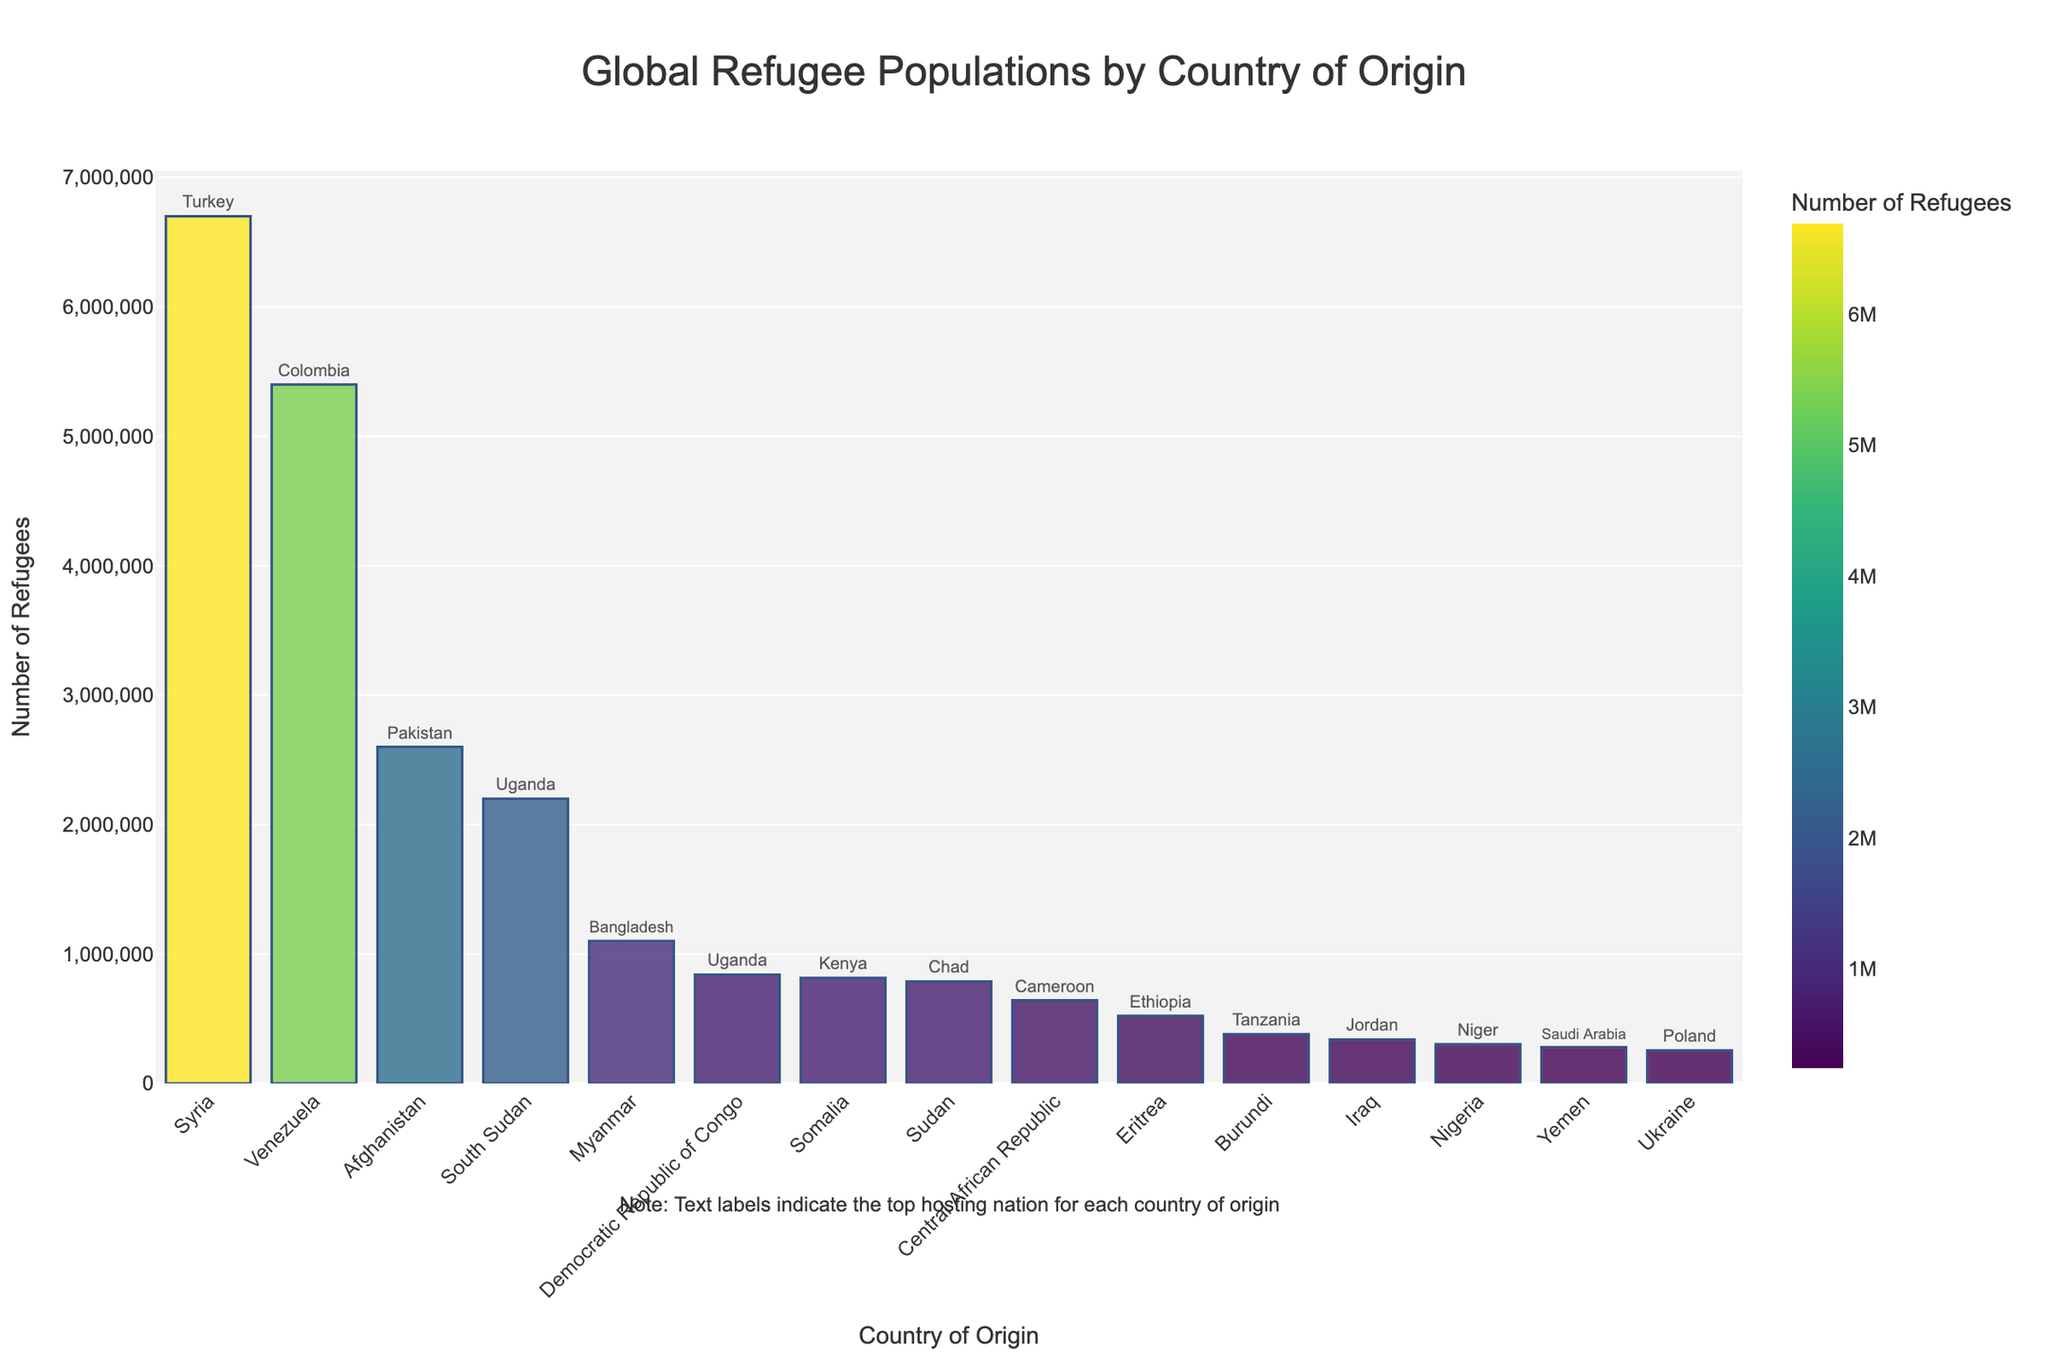What is the country of origin with the highest number of refugees? The bar chart shows that Syria has the highest number of refugees. This is evident from the tallest bar representing Syria.
Answer: Syria Which country of origin has the second largest number of refugees? The bar chart indicates that Venezuela has the second largest number of refugees by having the second tallest bar.
Answer: Venezuela How many more refugees are there from Syria compared to Afghanistan? From the bar chart, Syria has 6,700,000 refugees, and Afghanistan has 2,600,000 refugees. Subtracting these gives 6,700,000 - 2,600,000 = 4,100,000 more refugees from Syria.
Answer: 4,100,000 Which countries of origin have fewer than 1,000,000 refugees? The countries with bars shorter than those for South Sudan are Democratic Republic of Congo, Somalia, Sudan, Central African Republic, Eritrea, Burundi, Iraq, Nigeria, Yemen, and Ukraine.
Answer: Democratic Republic of Congo, Somalia, Sudan, Central African Republic, Eritrea, Burundi, Iraq, Nigeria, Yemen, Ukraine Among the countries listed, which top hosting nation has the highest number of refugees? The bar representing Syria indicates Turkey as the top hosting nation, with 6,700,000 refugees. Checking the other bars, this is indeed the highest figure for hosting refugees.
Answer: Turkey What is the difference in the refugee population between Myanmar and Sudan? Myanmar has 1,100,000 refugees, whereas Sudan has 788,000 refugees. The difference is 1,100,000 - 788,000 = 312,000 refugees.
Answer: 312,000 What is the total number of refugees from South Sudan and Democratic Republic of Congo combined? The bar chart shows South Sudan has 2,200,000 refugees, and Democratic Republic of Congo has 840,000 refugees. Adding these, 2,200,000 + 840,000 = 3,040,000 refugees combined.
Answer: 3,040,000 Which country of origin has the closest number of refugees to 800,000, and what is that exact number? Somalia has 815,000 refugees, which is closest to 800,000 among the listed countries.
Answer: Somalia, 815,000 Which country has the shortest bar in the chart, and what is the exact refugee count? Ukraine has the shortest bar in the chart, with 255,000 refugees.
Answer: Ukraine, 255,000 What is the average number of refugees from the countries listed on the bar chart? Summing across all bars, total refugees: 6,700,000 (Syria) + 5,400,000 (Venezuela) + 2,600,000 (Afghanistan) + 2,200,000 (South Sudan) + 1,100,000 (Myanmar) + 840,000 (Democratic Republic of Congo) + 815,000 (Somalia) + 788,000 (Sudan) + 642,000 (Central African Republic) + 522,000 (Eritrea) + 381,000 (Burundi) + 340,000 (Iraq) + 304,000 (Nigeria) + 280,000 (Yemen) + 255,000 (Ukraine) = 23,157,000. Total number of countries listed is 15. Average is 23,157,000 / 15 = 1,543,800 refugees.
Answer: 1,543,800 